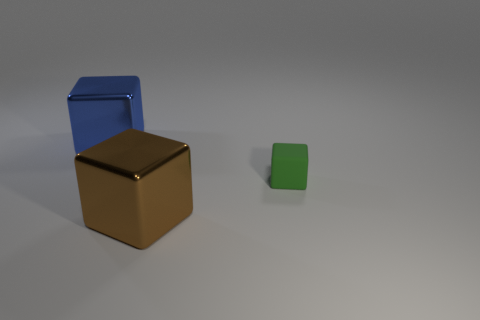Are the big blue object that is behind the brown object and the object right of the big brown block made of the same material?
Keep it short and to the point. No. The block that is behind the brown thing and to the left of the green block is what color?
Offer a very short reply. Blue. Is the number of small green rubber things that are to the right of the big blue metallic object greater than the number of large blue cubes in front of the green object?
Provide a short and direct response. Yes. What is the color of the large metallic cube behind the big brown thing?
Provide a succinct answer. Blue. There is a large object behind the small thing; is its shape the same as the thing that is on the right side of the brown shiny thing?
Offer a terse response. Yes. Is there a shiny block of the same size as the brown object?
Ensure brevity in your answer.  Yes. There is a big cube that is left of the brown metal thing; what is its material?
Provide a short and direct response. Metal. Does the block that is in front of the small rubber object have the same material as the large blue cube?
Give a very brief answer. Yes. Is there a small blue metal block?
Your response must be concise. No. What is the color of the cube that is made of the same material as the blue thing?
Your answer should be very brief. Brown. 